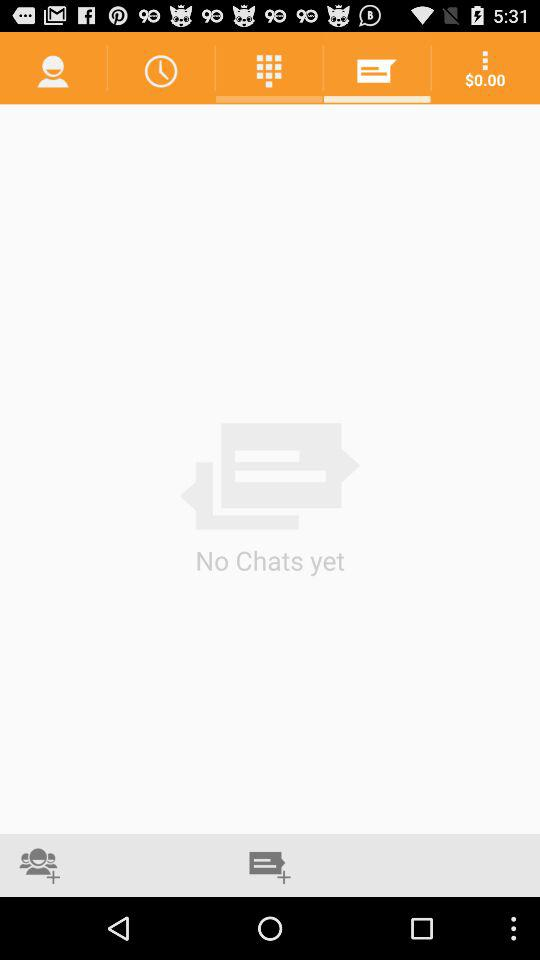How many chats are there? There are no chats. 